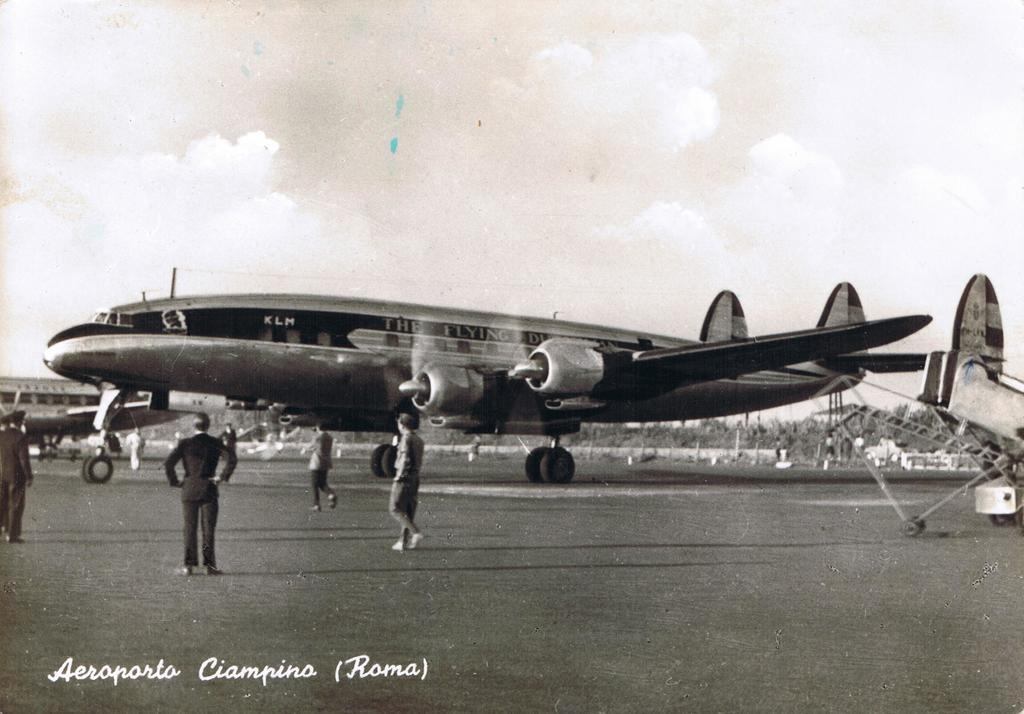<image>
Offer a succinct explanation of the picture presented. Postcard showing an airplane with the words Aeroporto on the bottom. 